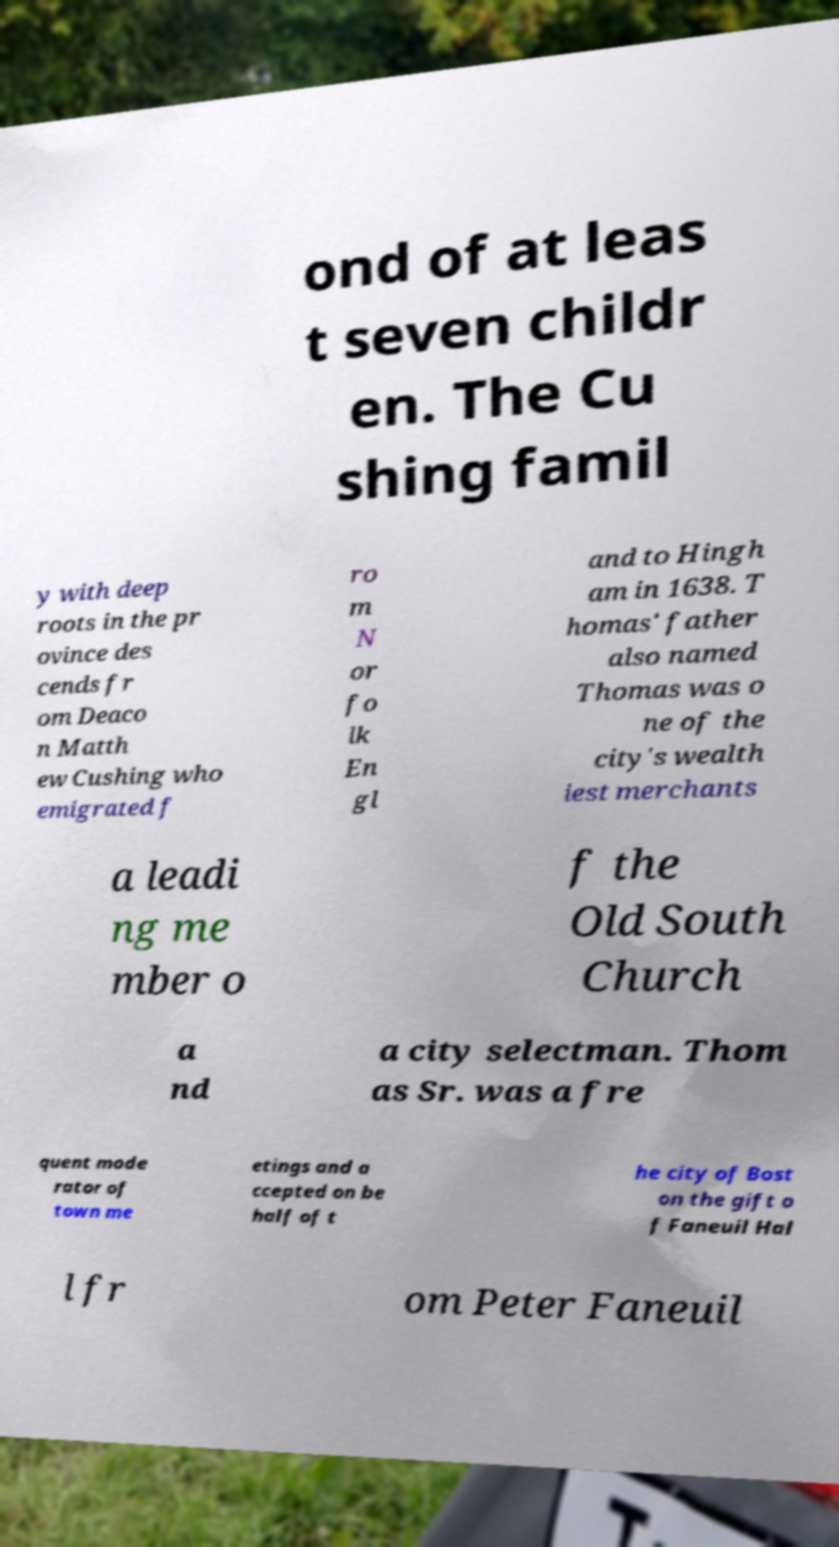For documentation purposes, I need the text within this image transcribed. Could you provide that? ond of at leas t seven childr en. The Cu shing famil y with deep roots in the pr ovince des cends fr om Deaco n Matth ew Cushing who emigrated f ro m N or fo lk En gl and to Hingh am in 1638. T homas' father also named Thomas was o ne of the city's wealth iest merchants a leadi ng me mber o f the Old South Church a nd a city selectman. Thom as Sr. was a fre quent mode rator of town me etings and a ccepted on be half of t he city of Bost on the gift o f Faneuil Hal l fr om Peter Faneuil 